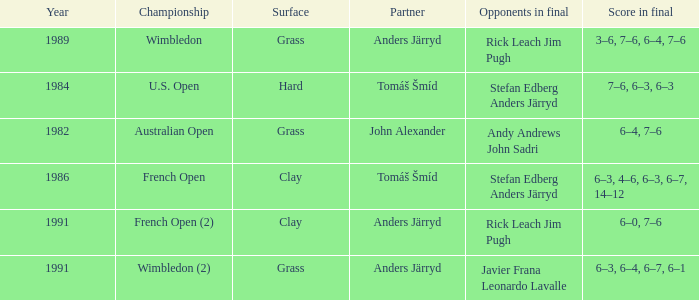Who was his partner in 1989?  Anders Järryd. 